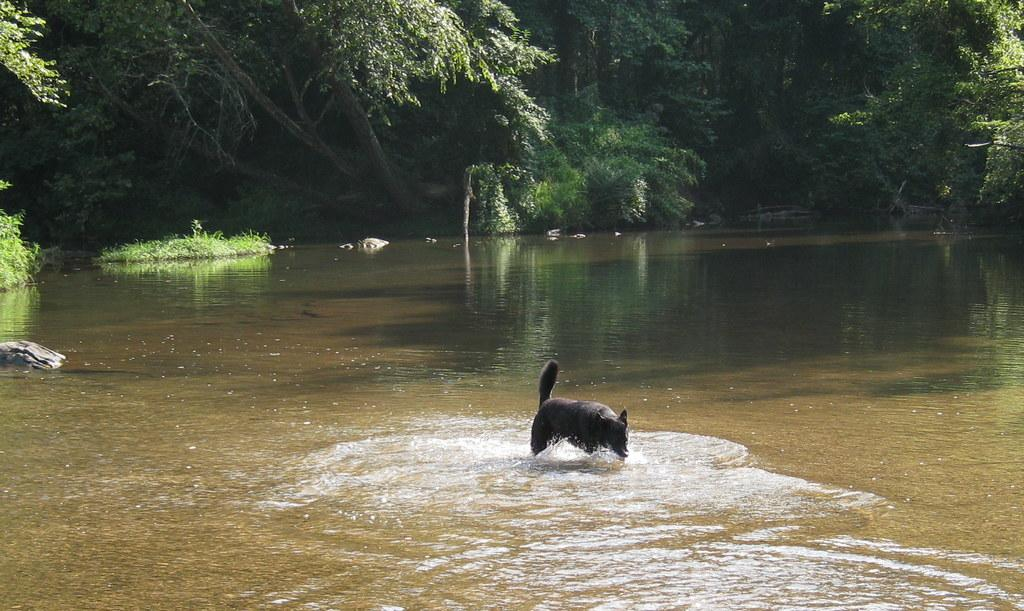What animal is present in the image? There is a dog in the image. Where is the dog located? The dog is on the surface of the lake. What can be seen in the background of the image? There are trees in the background of the image. What type of heart condition does the dog's dad have in the image? There is no mention of a dog's dad or any heart condition in the image. 